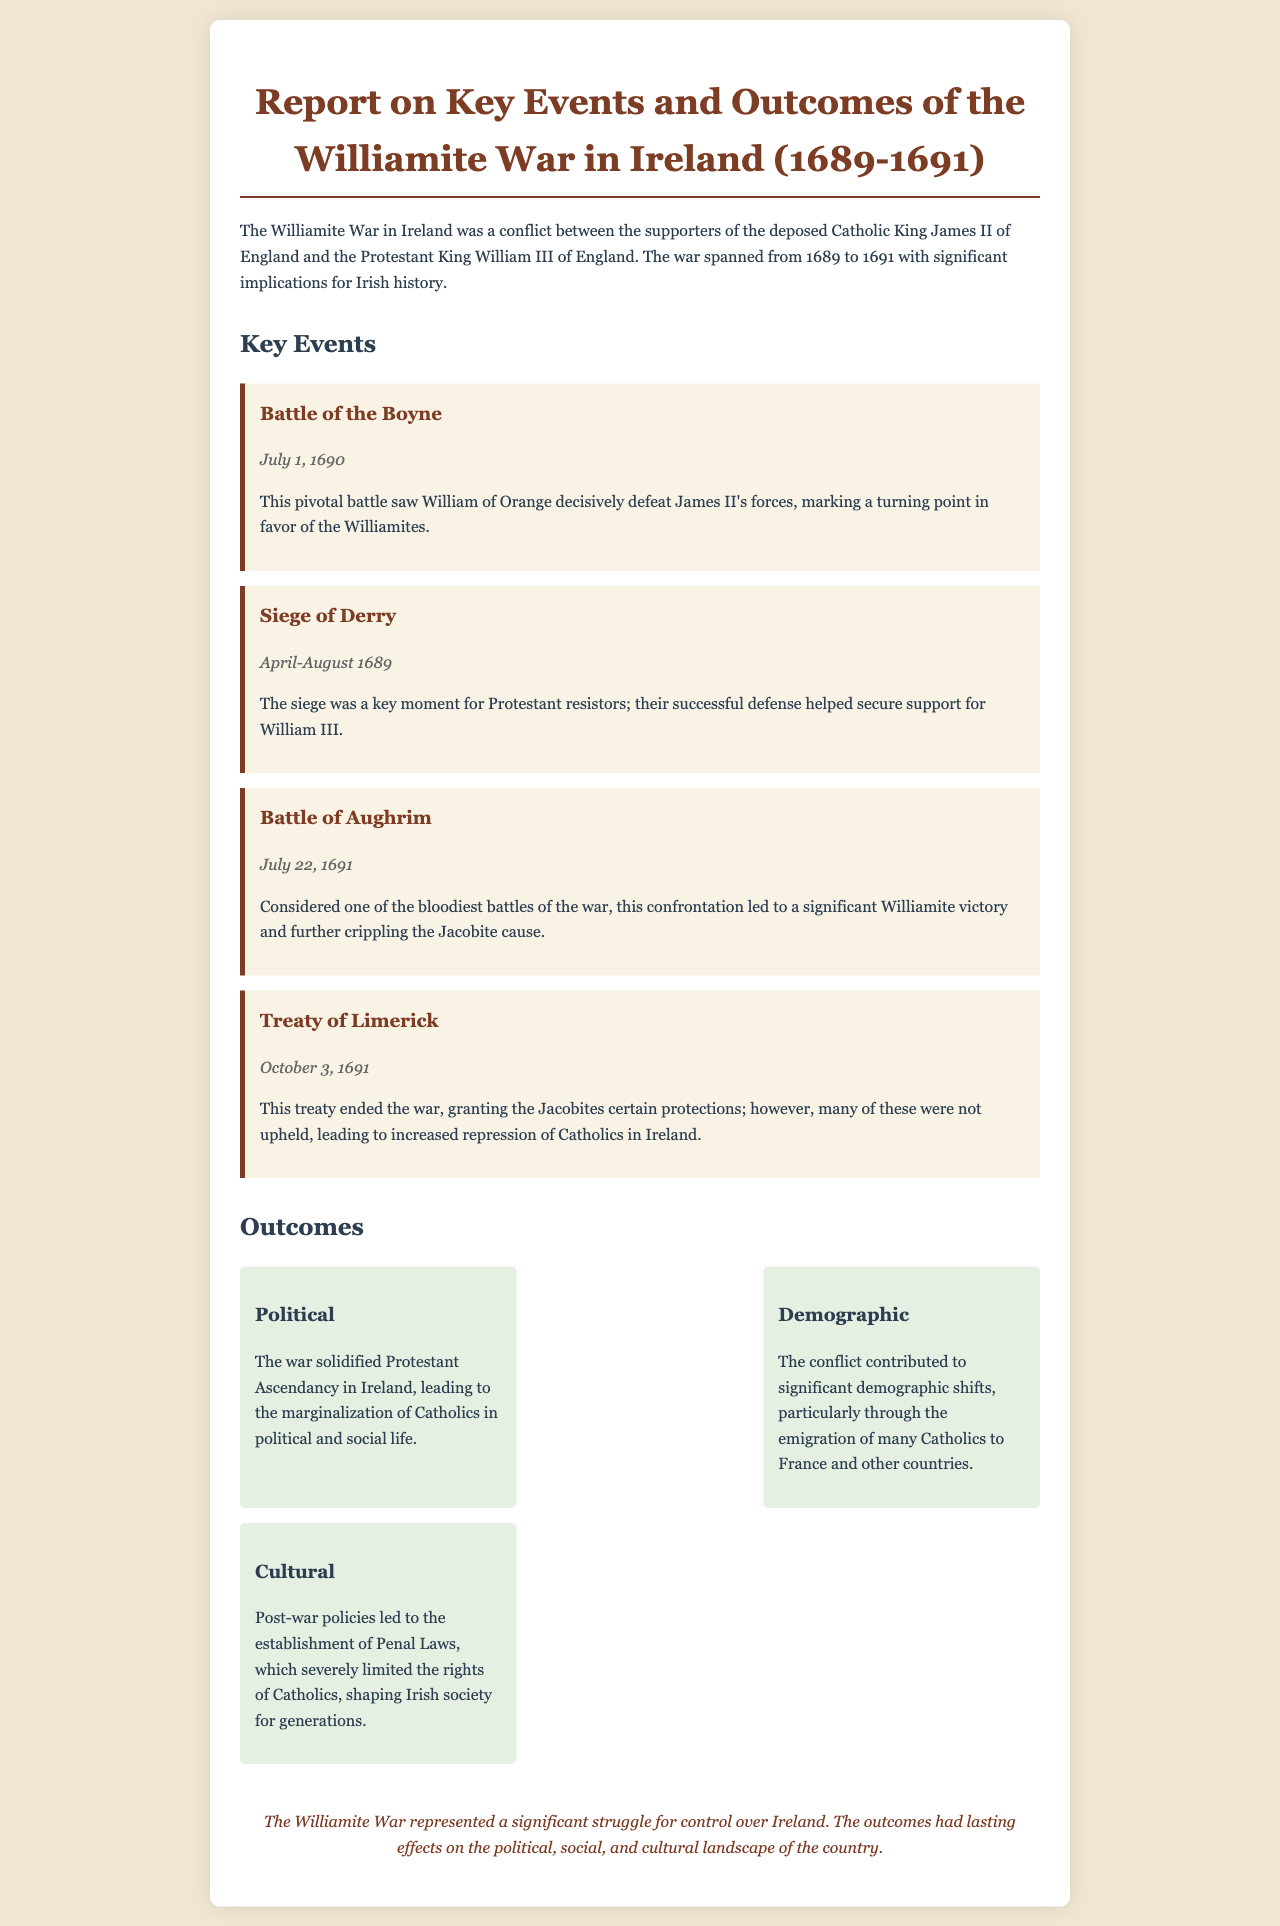What year did the Battle of the Boyne take place? The document states that the Battle of the Boyne occurred on July 1, 1690.
Answer: 1690 What was a significant outcome of the Siege of Derry? The document mentions that the successful defense of Derry helped secure support for William III.
Answer: Support for William III Which battle is considered the bloodiest of the war? According to the document, the Battle of Aughrim is described as one of the bloodiest battles.
Answer: Battle of Aughrim What treaty ended the Williamite War? The document indicates that the Treaty of Limerick ended the war on October 3, 1691.
Answer: Treaty of Limerick What law's establishment limited Catholics' rights post-war? The document notes that Penal Laws were established, limiting the rights of Catholics.
Answer: Penal Laws How did the war affect the demographic situation in Ireland? The document states there were significant demographic shifts due to the emigration of many Catholics.
Answer: Emigration of many Catholics What was one political outcome of the war? The document states that the war solidified Protestant Ascendancy in Ireland.
Answer: Protestant Ascendancy What was the timeframe of the Williamite War? The document specifies that the war spanned from 1689 to 1691.
Answer: 1689-1691 